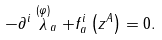<formula> <loc_0><loc_0><loc_500><loc_500>- \partial ^ { i } \stackrel { ( \varphi ) } { \lambda } _ { a } + f _ { a } ^ { i } \left ( z ^ { A } \right ) = 0 .</formula> 